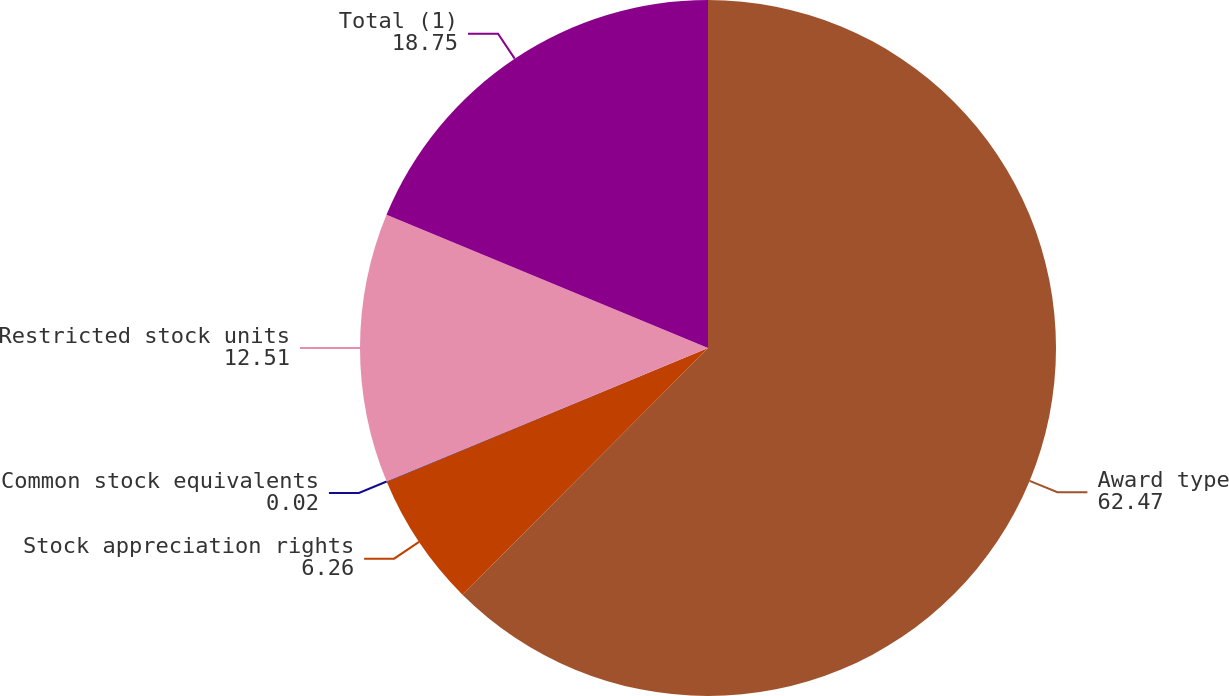Convert chart to OTSL. <chart><loc_0><loc_0><loc_500><loc_500><pie_chart><fcel>Award type<fcel>Stock appreciation rights<fcel>Common stock equivalents<fcel>Restricted stock units<fcel>Total (1)<nl><fcel>62.47%<fcel>6.26%<fcel>0.02%<fcel>12.51%<fcel>18.75%<nl></chart> 